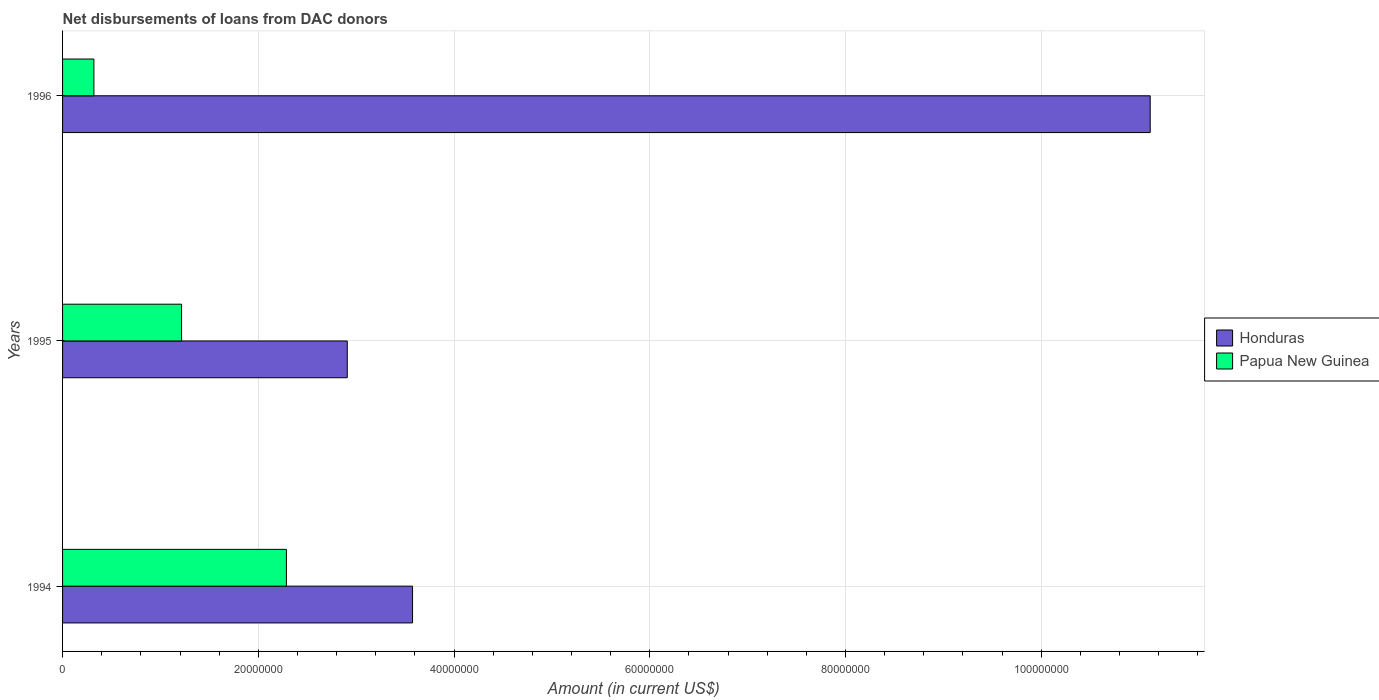How many different coloured bars are there?
Make the answer very short. 2. How many bars are there on the 1st tick from the bottom?
Offer a very short reply. 2. What is the amount of loans disbursed in Honduras in 1996?
Your response must be concise. 1.11e+08. Across all years, what is the maximum amount of loans disbursed in Papua New Guinea?
Your response must be concise. 2.29e+07. Across all years, what is the minimum amount of loans disbursed in Honduras?
Ensure brevity in your answer.  2.91e+07. What is the total amount of loans disbursed in Honduras in the graph?
Give a very brief answer. 1.76e+08. What is the difference between the amount of loans disbursed in Papua New Guinea in 1995 and that in 1996?
Provide a succinct answer. 8.96e+06. What is the difference between the amount of loans disbursed in Papua New Guinea in 1994 and the amount of loans disbursed in Honduras in 1995?
Ensure brevity in your answer.  -6.22e+06. What is the average amount of loans disbursed in Honduras per year?
Offer a very short reply. 5.87e+07. In the year 1996, what is the difference between the amount of loans disbursed in Honduras and amount of loans disbursed in Papua New Guinea?
Ensure brevity in your answer.  1.08e+08. What is the ratio of the amount of loans disbursed in Honduras in 1994 to that in 1996?
Provide a short and direct response. 0.32. Is the amount of loans disbursed in Honduras in 1994 less than that in 1995?
Provide a succinct answer. No. What is the difference between the highest and the second highest amount of loans disbursed in Honduras?
Provide a short and direct response. 7.54e+07. What is the difference between the highest and the lowest amount of loans disbursed in Honduras?
Your answer should be very brief. 8.20e+07. Is the sum of the amount of loans disbursed in Papua New Guinea in 1995 and 1996 greater than the maximum amount of loans disbursed in Honduras across all years?
Provide a short and direct response. No. What does the 1st bar from the top in 1996 represents?
Provide a succinct answer. Papua New Guinea. What does the 1st bar from the bottom in 1996 represents?
Ensure brevity in your answer.  Honduras. How many bars are there?
Offer a very short reply. 6. What is the difference between two consecutive major ticks on the X-axis?
Give a very brief answer. 2.00e+07. Does the graph contain any zero values?
Provide a succinct answer. No. Does the graph contain grids?
Your response must be concise. Yes. How are the legend labels stacked?
Make the answer very short. Vertical. What is the title of the graph?
Your answer should be very brief. Net disbursements of loans from DAC donors. Does "China" appear as one of the legend labels in the graph?
Keep it short and to the point. No. What is the label or title of the X-axis?
Provide a succinct answer. Amount (in current US$). What is the Amount (in current US$) of Honduras in 1994?
Make the answer very short. 3.58e+07. What is the Amount (in current US$) in Papua New Guinea in 1994?
Your response must be concise. 2.29e+07. What is the Amount (in current US$) of Honduras in 1995?
Keep it short and to the point. 2.91e+07. What is the Amount (in current US$) of Papua New Guinea in 1995?
Provide a short and direct response. 1.22e+07. What is the Amount (in current US$) in Honduras in 1996?
Offer a very short reply. 1.11e+08. What is the Amount (in current US$) in Papua New Guinea in 1996?
Provide a short and direct response. 3.20e+06. Across all years, what is the maximum Amount (in current US$) of Honduras?
Offer a terse response. 1.11e+08. Across all years, what is the maximum Amount (in current US$) of Papua New Guinea?
Ensure brevity in your answer.  2.29e+07. Across all years, what is the minimum Amount (in current US$) of Honduras?
Provide a succinct answer. 2.91e+07. Across all years, what is the minimum Amount (in current US$) of Papua New Guinea?
Keep it short and to the point. 3.20e+06. What is the total Amount (in current US$) of Honduras in the graph?
Make the answer very short. 1.76e+08. What is the total Amount (in current US$) in Papua New Guinea in the graph?
Provide a succinct answer. 3.82e+07. What is the difference between the Amount (in current US$) of Honduras in 1994 and that in 1995?
Give a very brief answer. 6.67e+06. What is the difference between the Amount (in current US$) in Papua New Guinea in 1994 and that in 1995?
Offer a terse response. 1.07e+07. What is the difference between the Amount (in current US$) of Honduras in 1994 and that in 1996?
Keep it short and to the point. -7.54e+07. What is the difference between the Amount (in current US$) in Papua New Guinea in 1994 and that in 1996?
Provide a succinct answer. 1.97e+07. What is the difference between the Amount (in current US$) of Honduras in 1995 and that in 1996?
Make the answer very short. -8.20e+07. What is the difference between the Amount (in current US$) in Papua New Guinea in 1995 and that in 1996?
Make the answer very short. 8.96e+06. What is the difference between the Amount (in current US$) of Honduras in 1994 and the Amount (in current US$) of Papua New Guinea in 1995?
Offer a very short reply. 2.36e+07. What is the difference between the Amount (in current US$) of Honduras in 1994 and the Amount (in current US$) of Papua New Guinea in 1996?
Provide a short and direct response. 3.26e+07. What is the difference between the Amount (in current US$) in Honduras in 1995 and the Amount (in current US$) in Papua New Guinea in 1996?
Ensure brevity in your answer.  2.59e+07. What is the average Amount (in current US$) of Honduras per year?
Offer a terse response. 5.87e+07. What is the average Amount (in current US$) of Papua New Guinea per year?
Provide a succinct answer. 1.27e+07. In the year 1994, what is the difference between the Amount (in current US$) of Honduras and Amount (in current US$) of Papua New Guinea?
Your answer should be compact. 1.29e+07. In the year 1995, what is the difference between the Amount (in current US$) in Honduras and Amount (in current US$) in Papua New Guinea?
Offer a terse response. 1.69e+07. In the year 1996, what is the difference between the Amount (in current US$) in Honduras and Amount (in current US$) in Papua New Guinea?
Make the answer very short. 1.08e+08. What is the ratio of the Amount (in current US$) in Honduras in 1994 to that in 1995?
Offer a terse response. 1.23. What is the ratio of the Amount (in current US$) in Papua New Guinea in 1994 to that in 1995?
Provide a succinct answer. 1.88. What is the ratio of the Amount (in current US$) in Honduras in 1994 to that in 1996?
Give a very brief answer. 0.32. What is the ratio of the Amount (in current US$) of Papua New Guinea in 1994 to that in 1996?
Your answer should be very brief. 7.14. What is the ratio of the Amount (in current US$) of Honduras in 1995 to that in 1996?
Provide a succinct answer. 0.26. What is the ratio of the Amount (in current US$) in Papua New Guinea in 1995 to that in 1996?
Give a very brief answer. 3.8. What is the difference between the highest and the second highest Amount (in current US$) in Honduras?
Your answer should be compact. 7.54e+07. What is the difference between the highest and the second highest Amount (in current US$) of Papua New Guinea?
Your answer should be compact. 1.07e+07. What is the difference between the highest and the lowest Amount (in current US$) of Honduras?
Provide a succinct answer. 8.20e+07. What is the difference between the highest and the lowest Amount (in current US$) of Papua New Guinea?
Offer a terse response. 1.97e+07. 